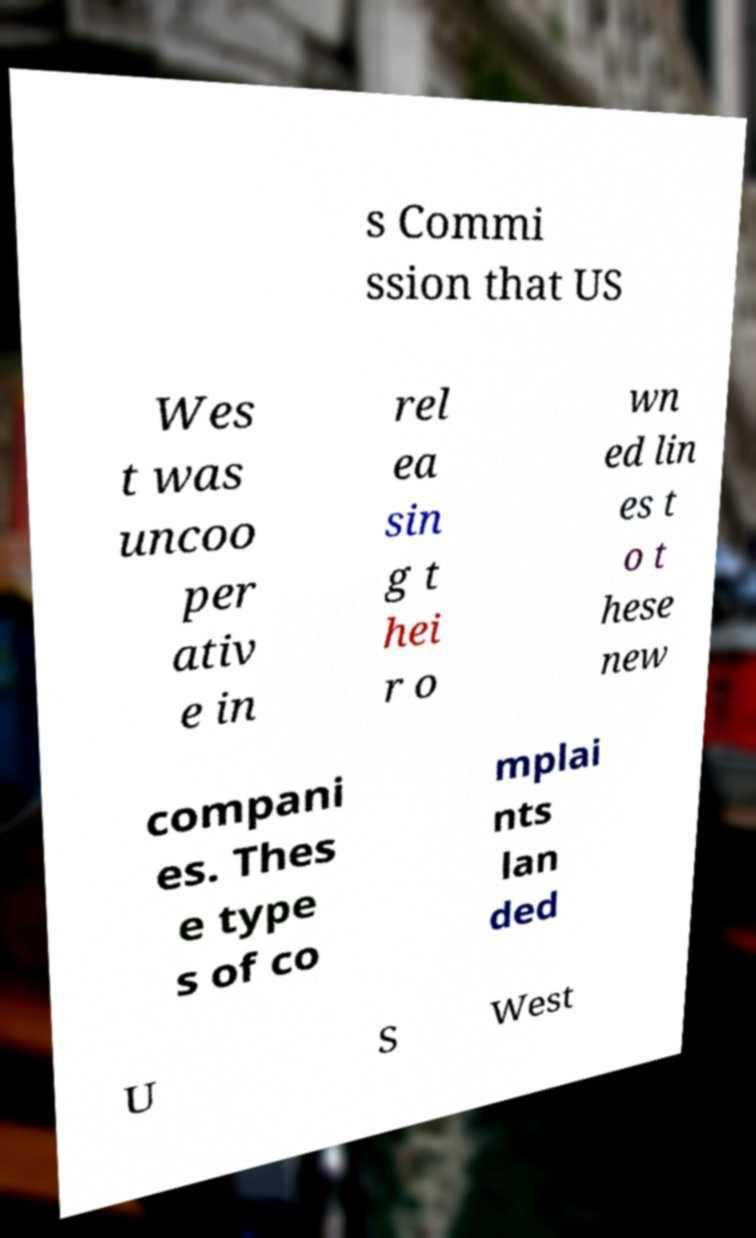Could you assist in decoding the text presented in this image and type it out clearly? s Commi ssion that US Wes t was uncoo per ativ e in rel ea sin g t hei r o wn ed lin es t o t hese new compani es. Thes e type s of co mplai nts lan ded U S West 